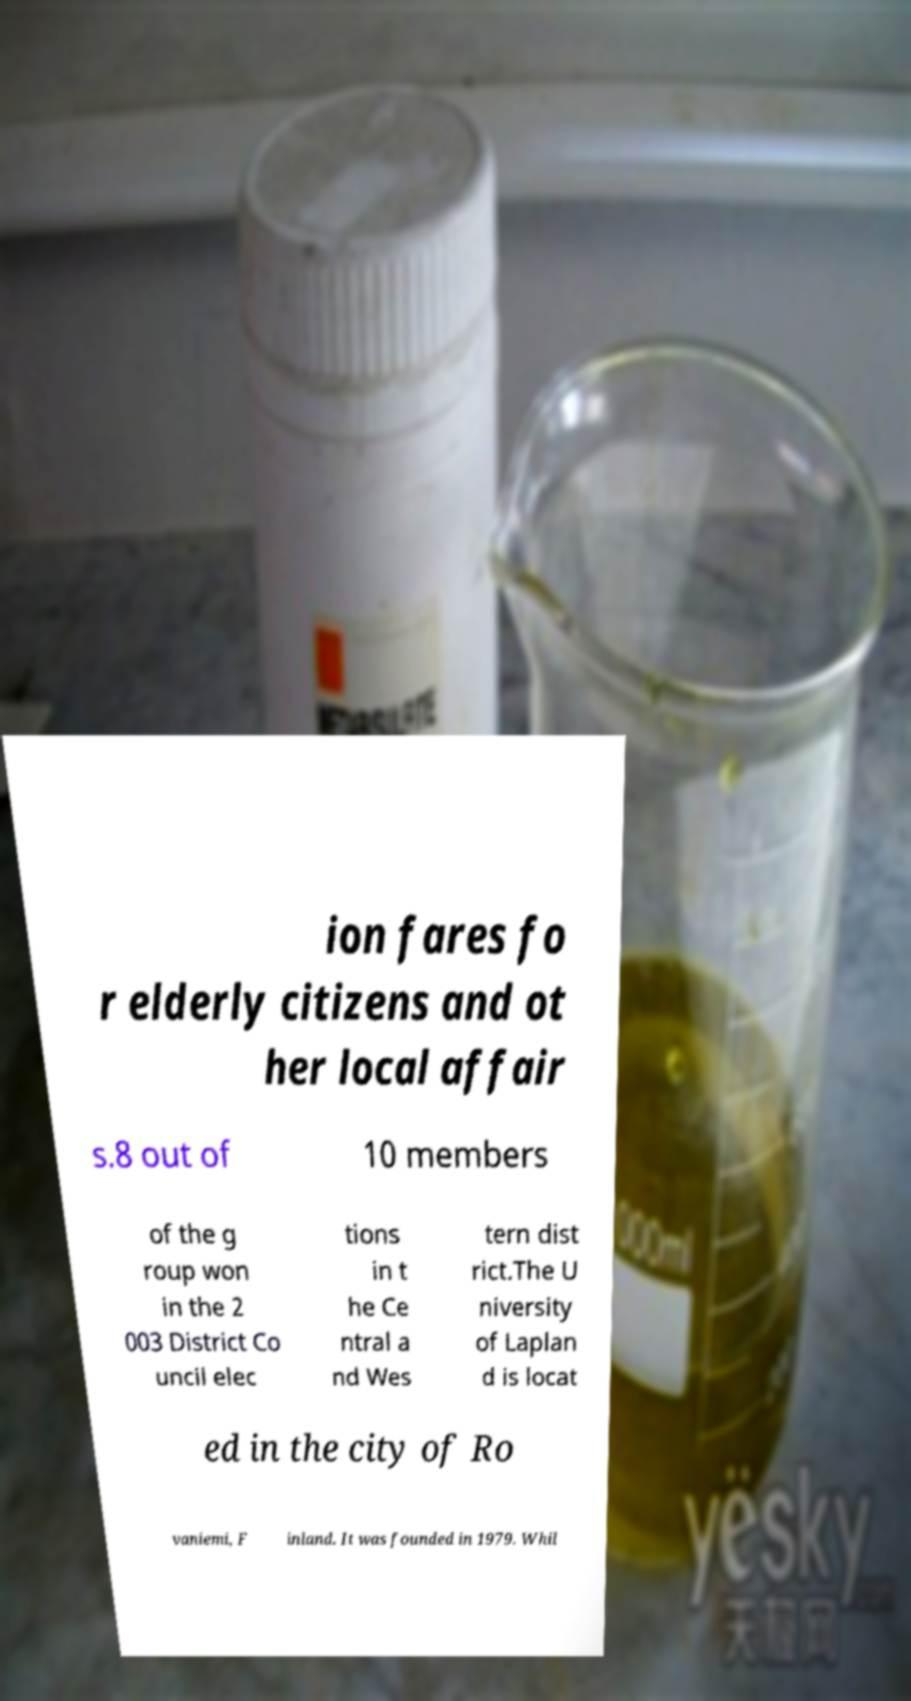Could you extract and type out the text from this image? ion fares fo r elderly citizens and ot her local affair s.8 out of 10 members of the g roup won in the 2 003 District Co uncil elec tions in t he Ce ntral a nd Wes tern dist rict.The U niversity of Laplan d is locat ed in the city of Ro vaniemi, F inland. It was founded in 1979. Whil 